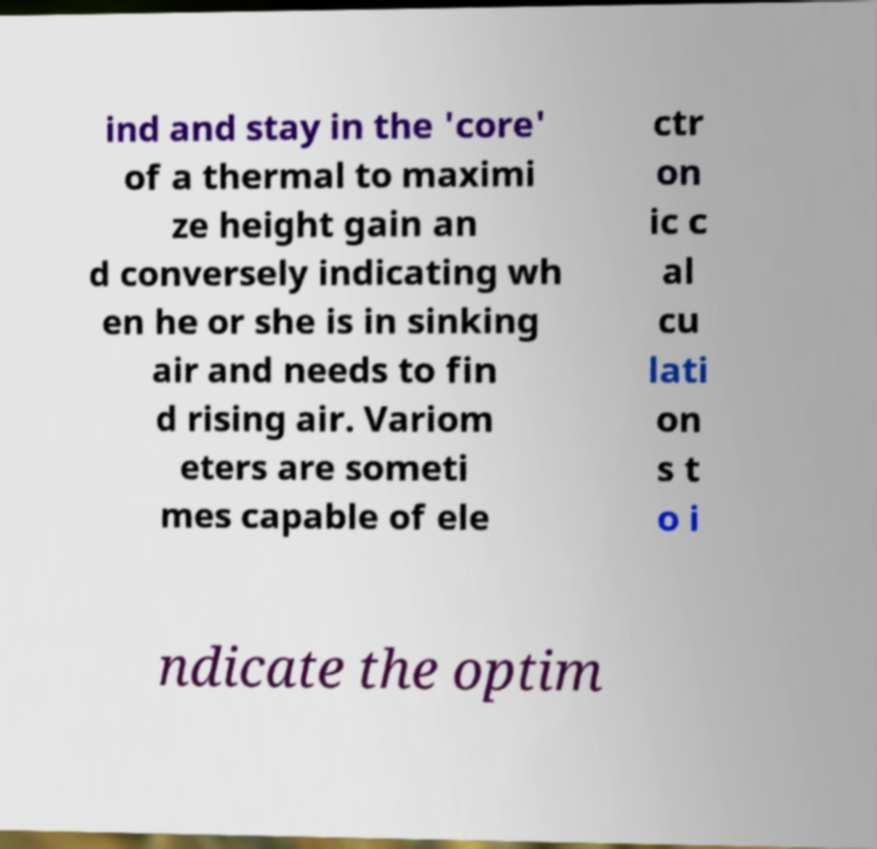Can you accurately transcribe the text from the provided image for me? ind and stay in the 'core' of a thermal to maximi ze height gain an d conversely indicating wh en he or she is in sinking air and needs to fin d rising air. Variom eters are someti mes capable of ele ctr on ic c al cu lati on s t o i ndicate the optim 